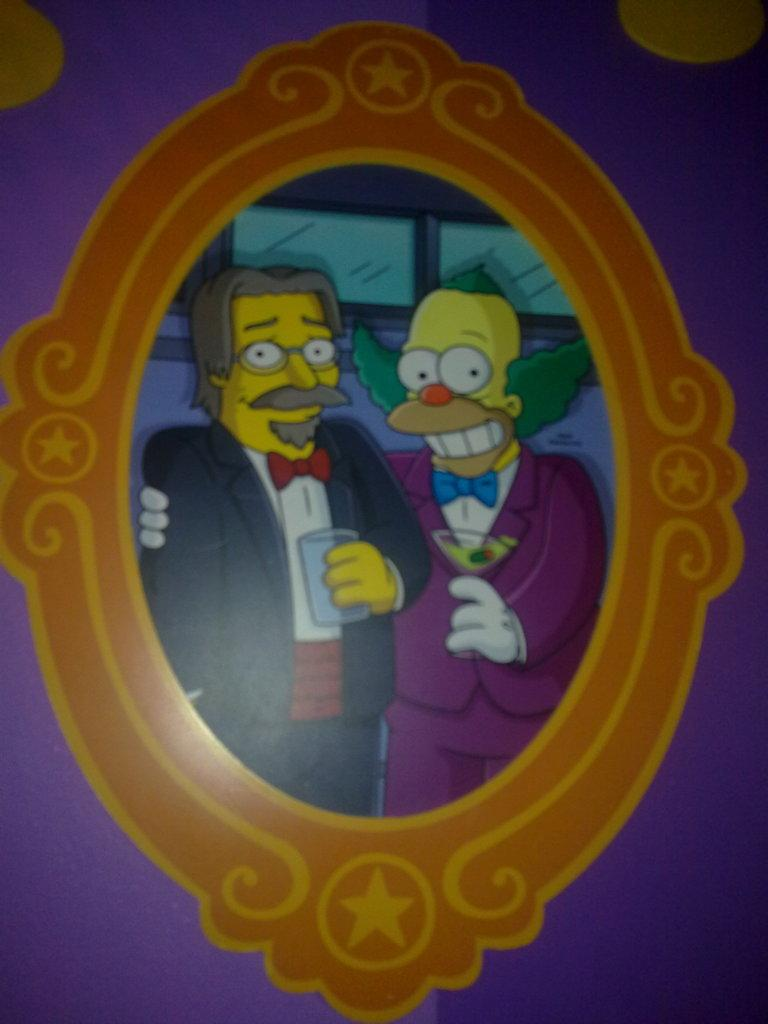What style is the image drawn in? The image is a cartoon. How many people are in the image? There are two people in the image. What are the people doing in the image? The people are standing and holding glasses in their hands. Can the image be considered a single frame? Yes, the image can be considered a frame. What type of stick can be seen in the hands of the people in the image? There is no stick present in the hands of the people in the image; they are holding glasses. Is the image a work of fiction or non-fiction? The image is a cartoon, which is a form of fiction. 